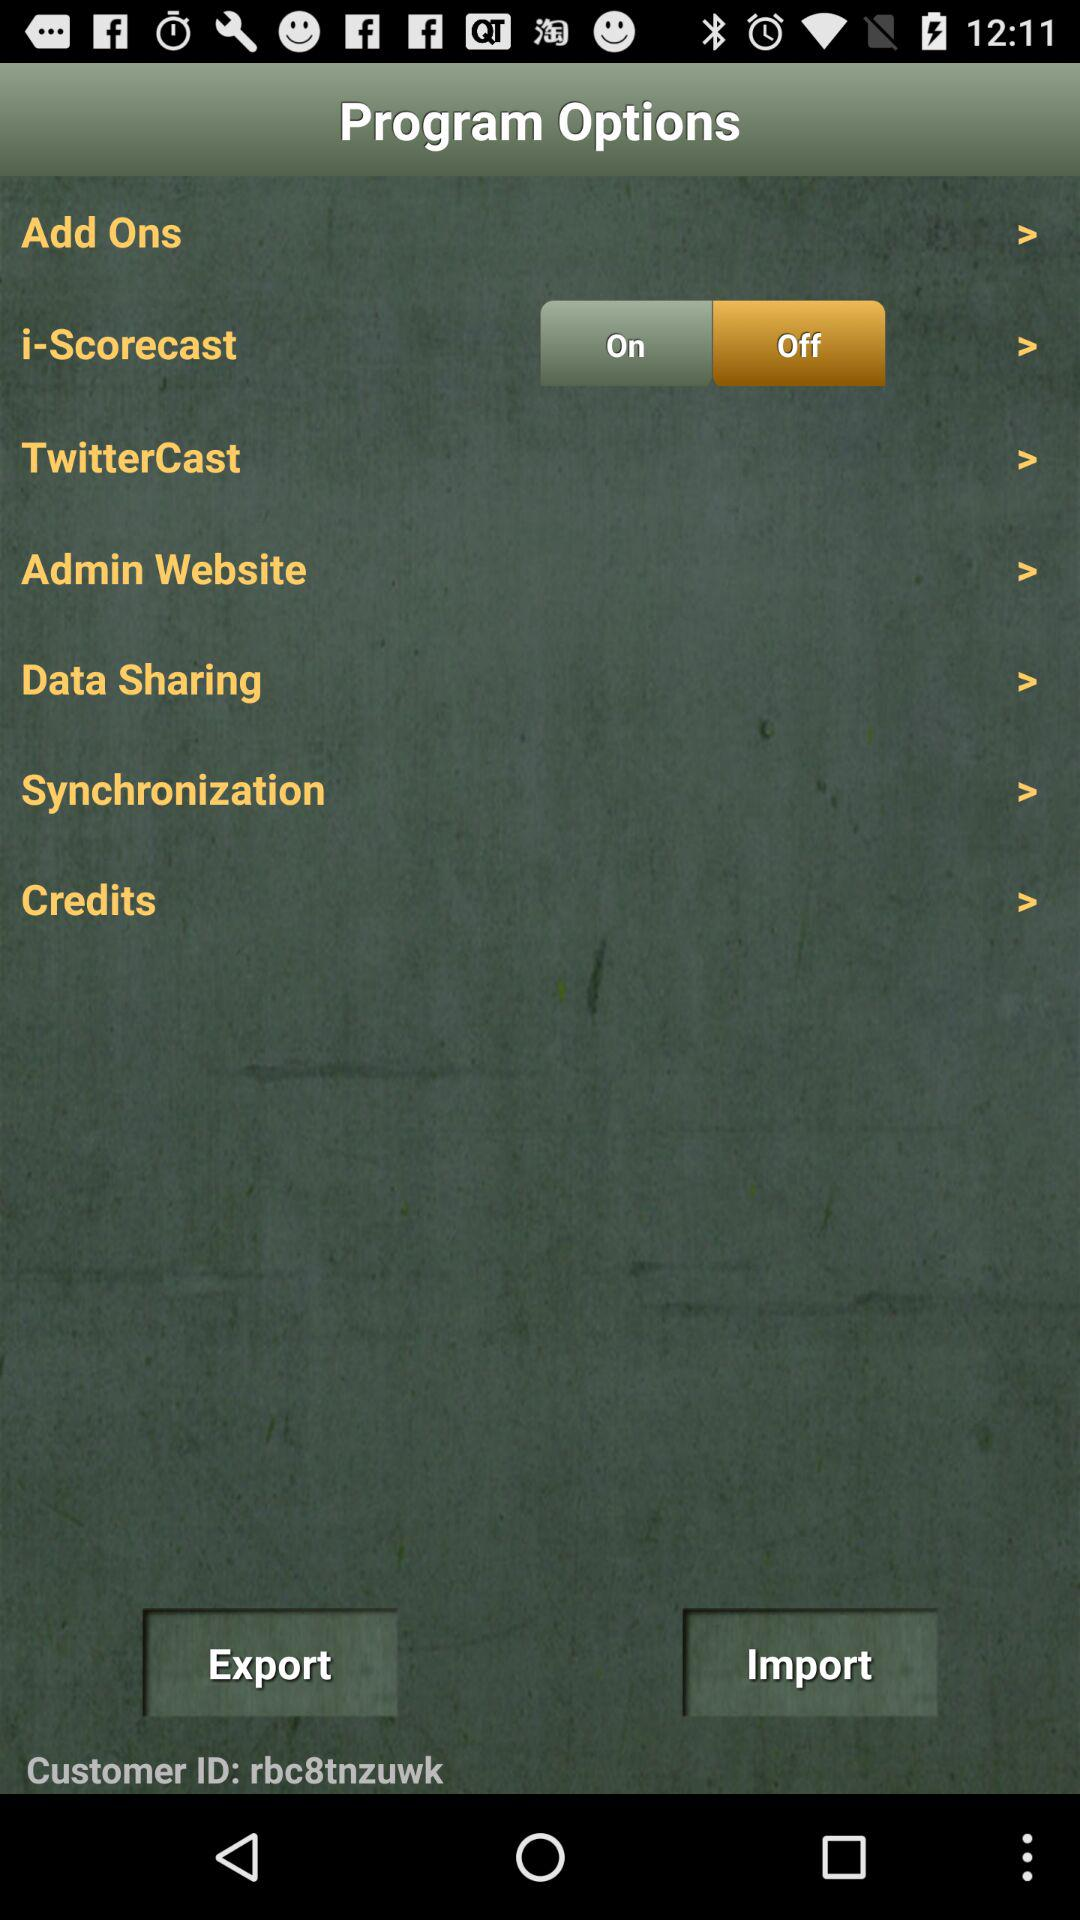What is the status of the "i-Scorecast"? The status is "off". 